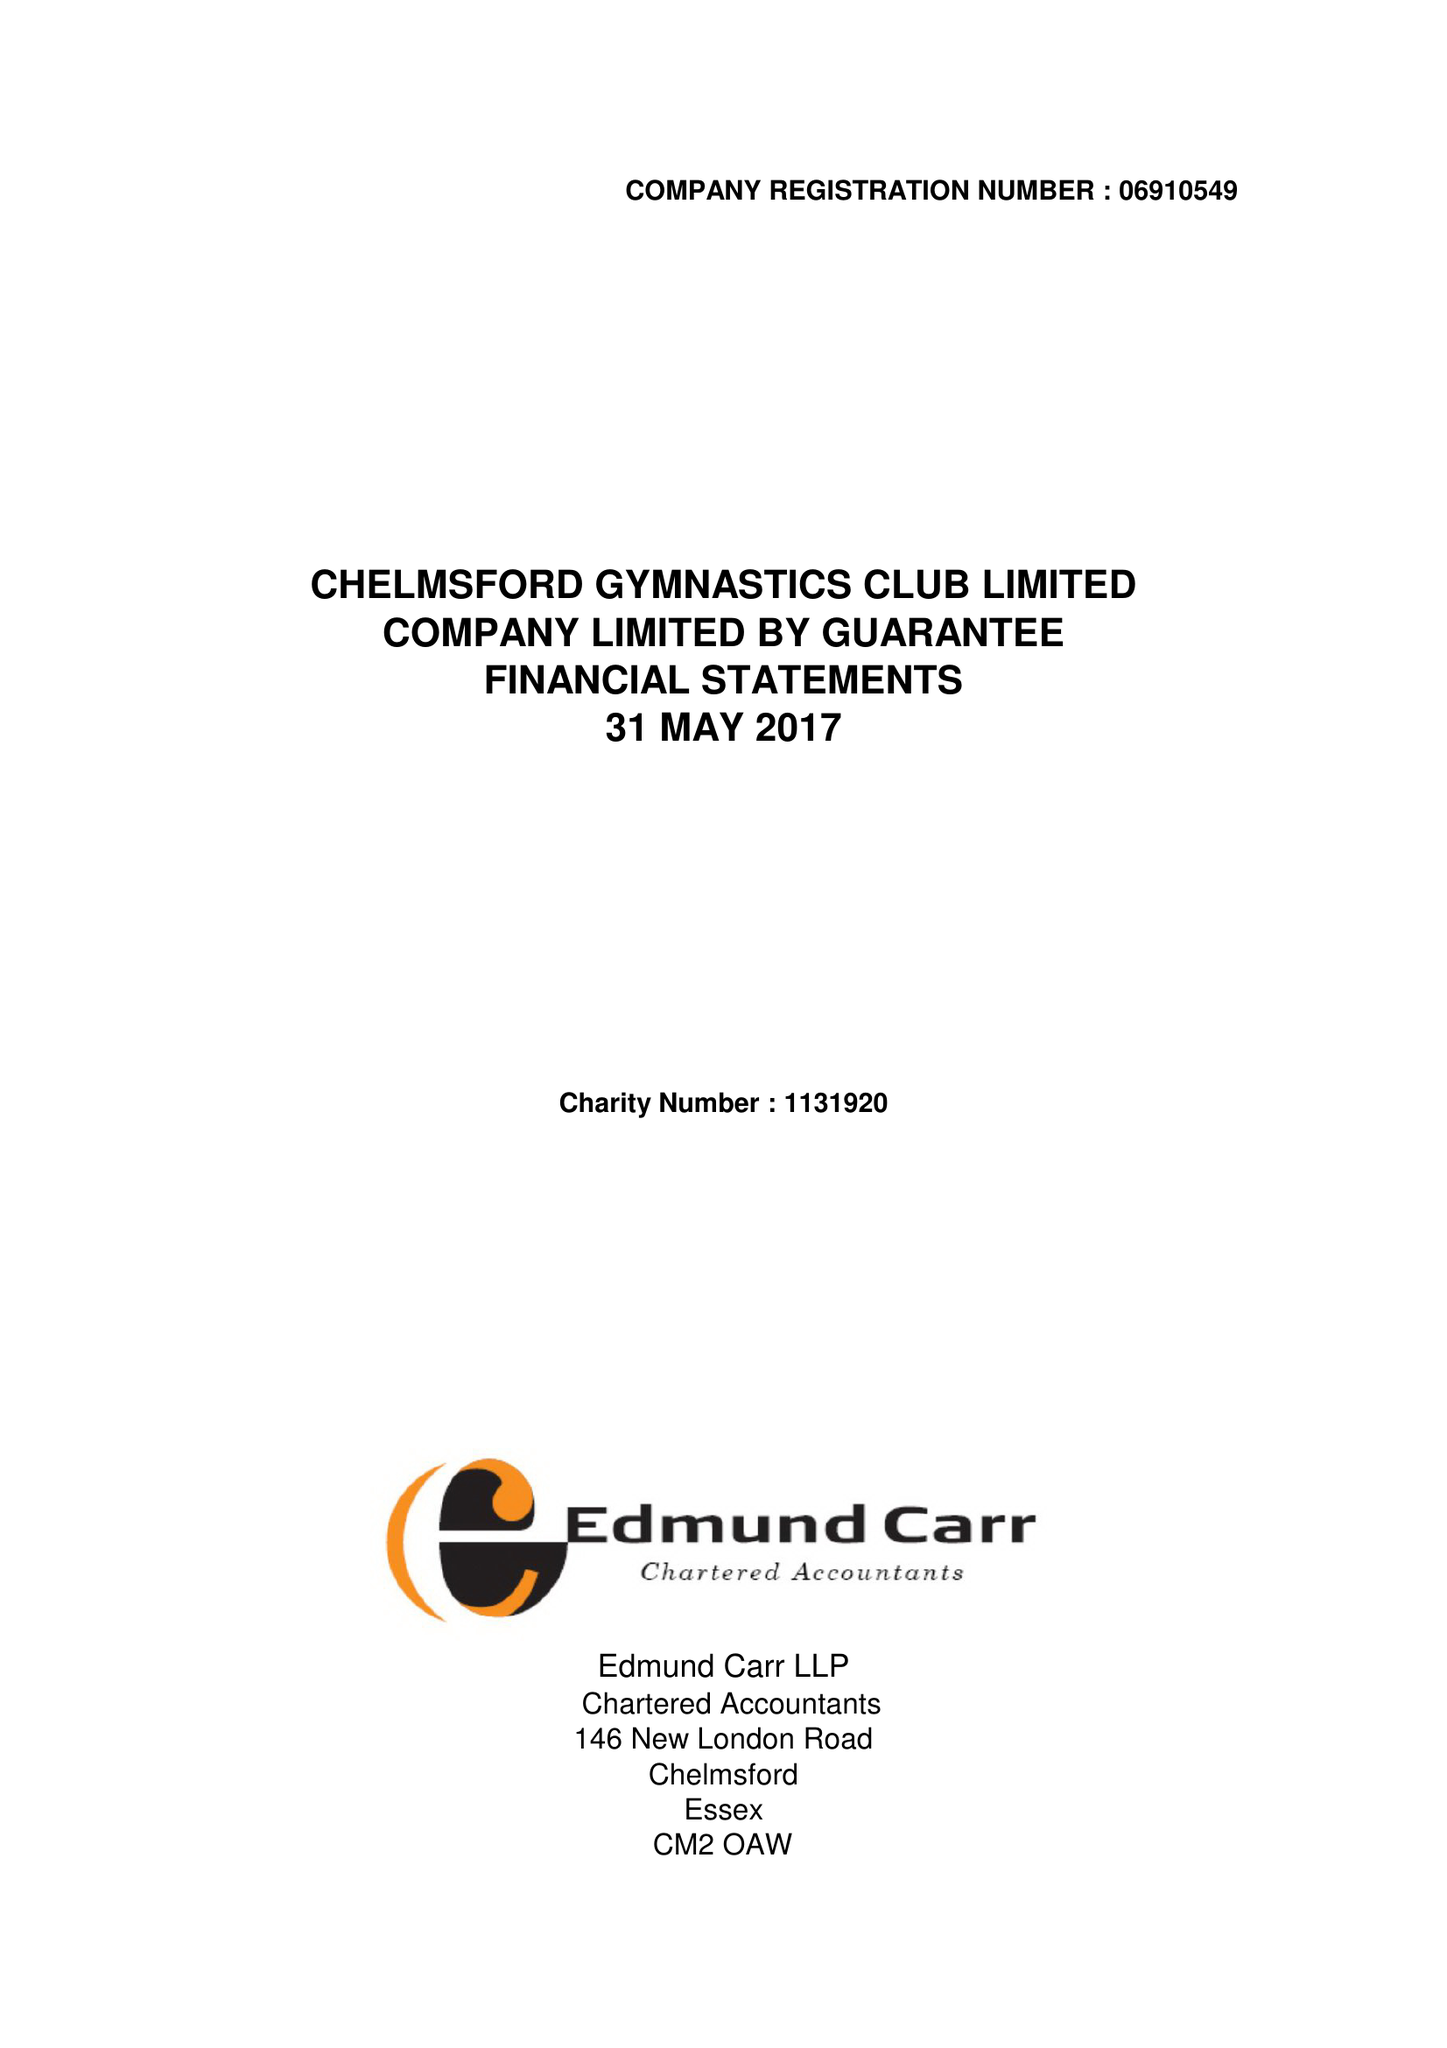What is the value for the charity_name?
Answer the question using a single word or phrase. Chelmsford Gymnastics Club Ltd. 